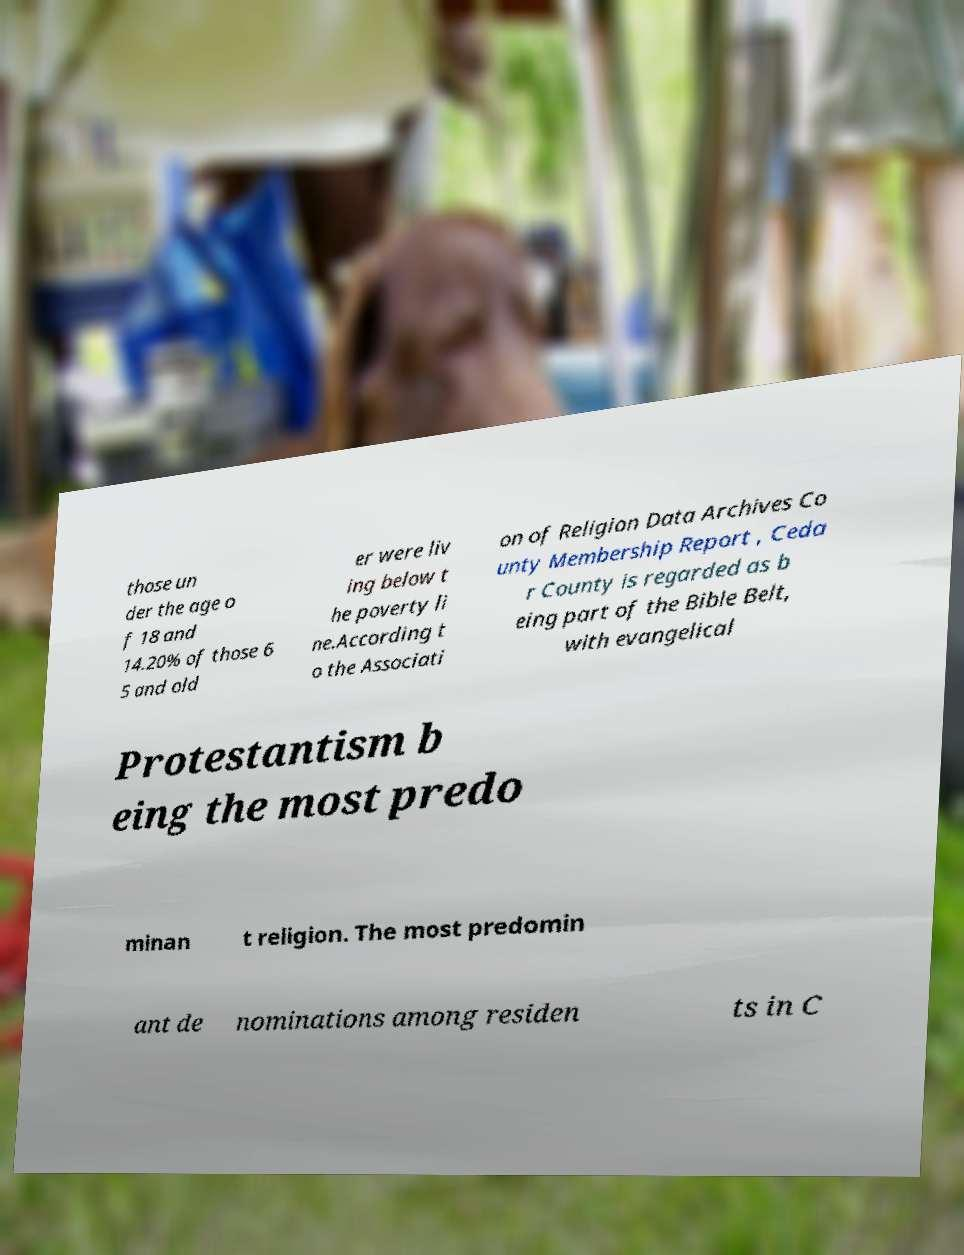Please identify and transcribe the text found in this image. those un der the age o f 18 and 14.20% of those 6 5 and old er were liv ing below t he poverty li ne.According t o the Associati on of Religion Data Archives Co unty Membership Report , Ceda r County is regarded as b eing part of the Bible Belt, with evangelical Protestantism b eing the most predo minan t religion. The most predomin ant de nominations among residen ts in C 